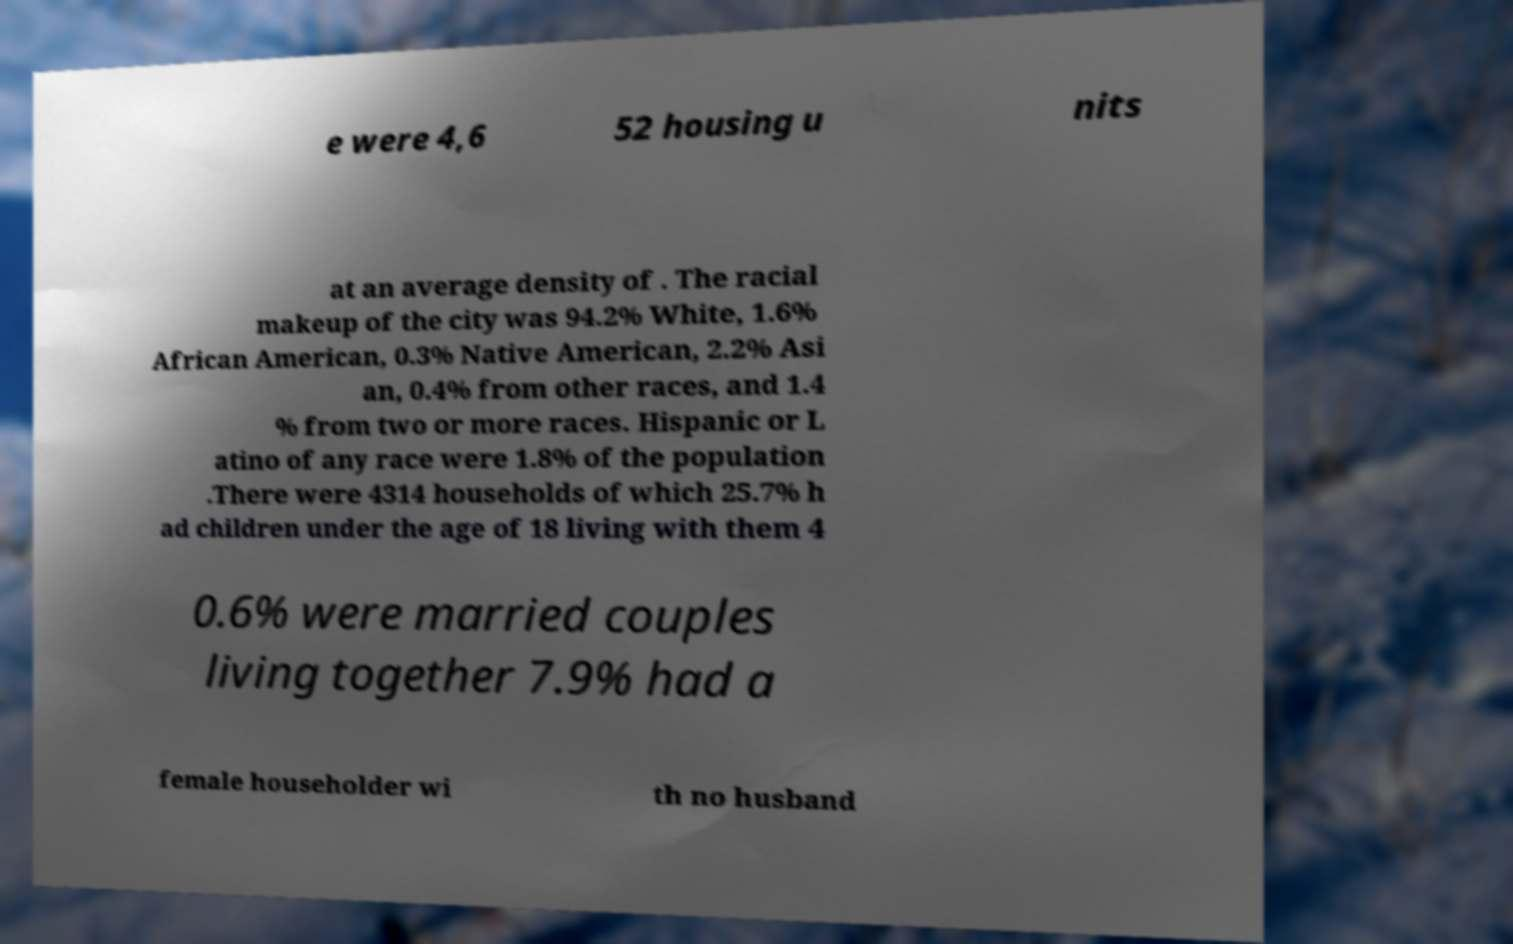For documentation purposes, I need the text within this image transcribed. Could you provide that? e were 4,6 52 housing u nits at an average density of . The racial makeup of the city was 94.2% White, 1.6% African American, 0.3% Native American, 2.2% Asi an, 0.4% from other races, and 1.4 % from two or more races. Hispanic or L atino of any race were 1.8% of the population .There were 4314 households of which 25.7% h ad children under the age of 18 living with them 4 0.6% were married couples living together 7.9% had a female householder wi th no husband 